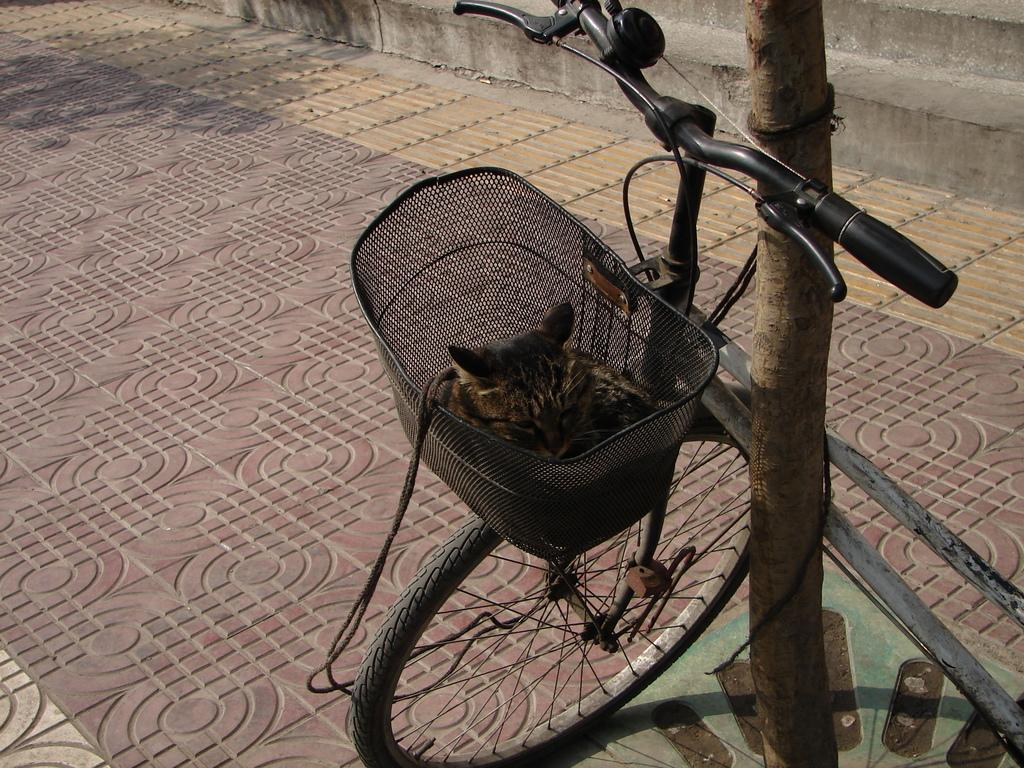What is the main object in the image? There is a bicycle in the image. What else can be seen in the image besides the bicycle? There is a tree stem and stairs in the image. What song is being sung by the bicycle in the image? There is no indication in the image that the bicycle is singing a song, as bicycles do not have the ability to sing. 